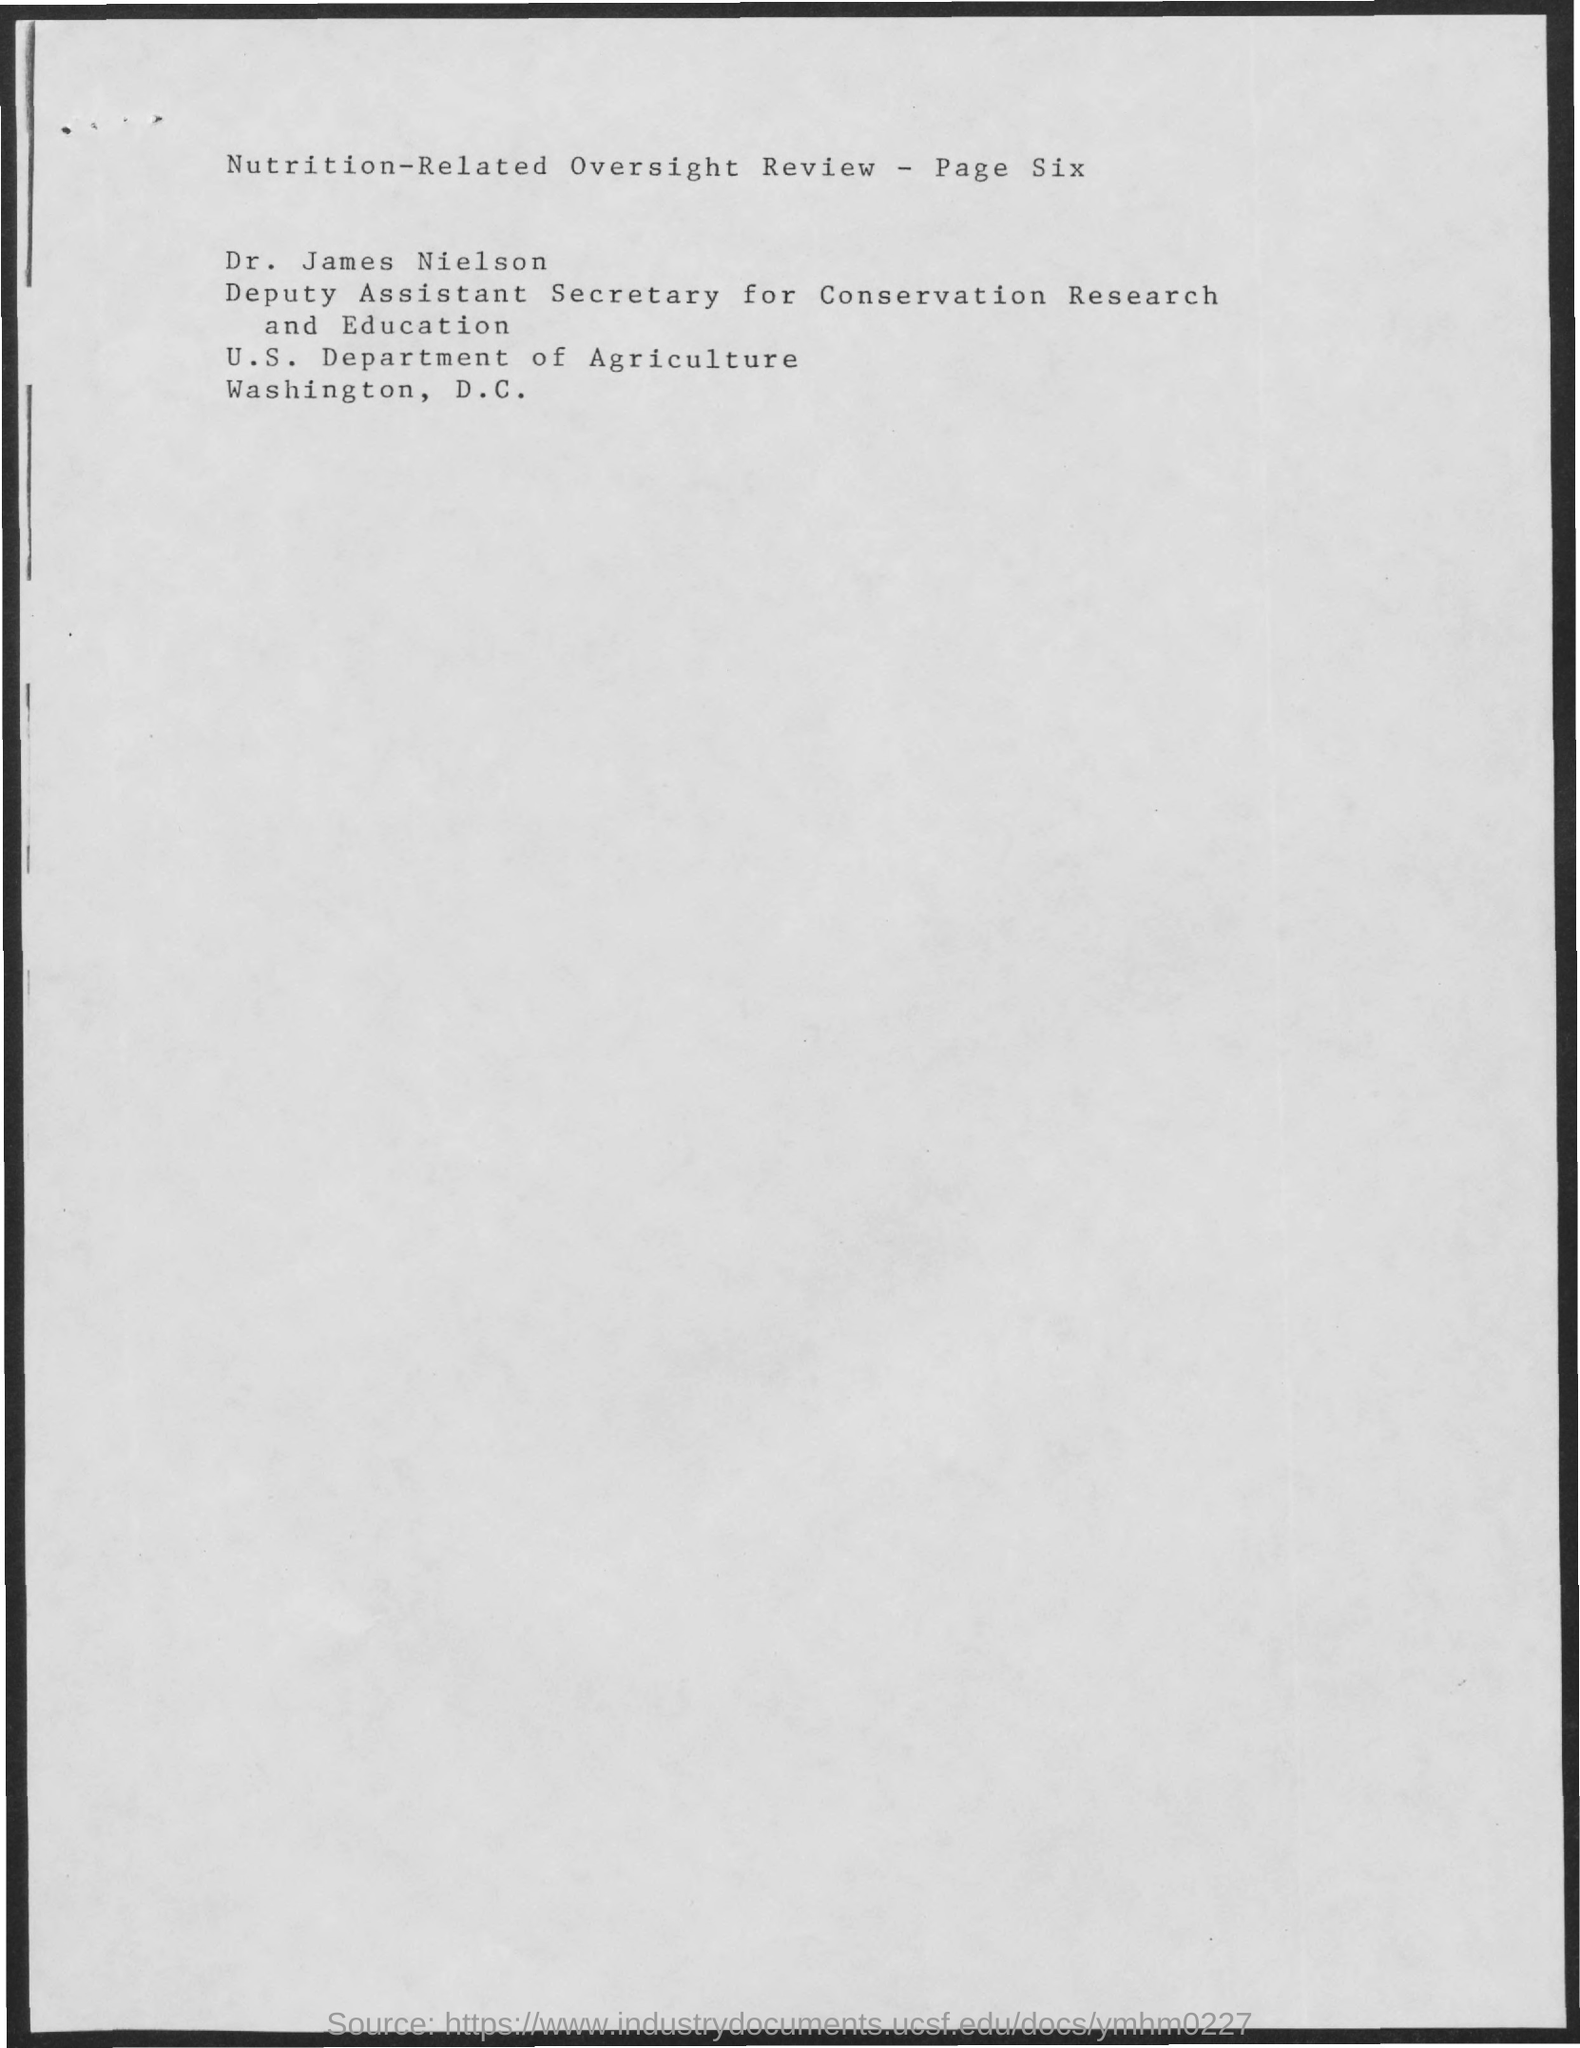What is the review about?
Your response must be concise. Nutrition-Related Oversight Review. What is the designation of dr. james nielson?
Your answer should be very brief. Deputy Assistant Secretary for Conservation Research and Education. Which department Dr. James Neilson works for?
Your answer should be compact. U. S. department of agriculture. Which city is the U.S. Department of agriculture in?
Ensure brevity in your answer.  Washington, D.C. What is the page number?
Provide a succinct answer. Six. 